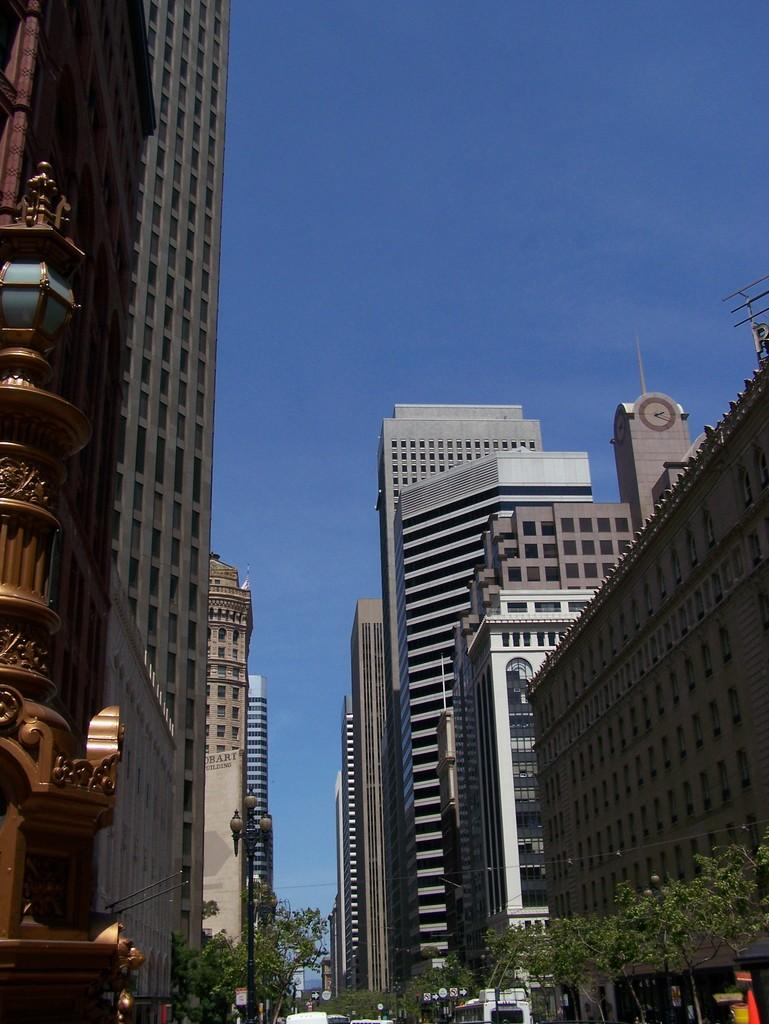What type of structures can be seen in the image? There are many buildings in the image. What else can be seen in the image besides buildings? There are many trees in the image. Can you identify any specific building in the image? Yes, there is a clock tower building in the image. What type of cabbage is growing on top of the clock tower building in the image? There is no cabbage growing on top of the clock tower building in the image; it is a clock tower building, not a vegetable garden. 